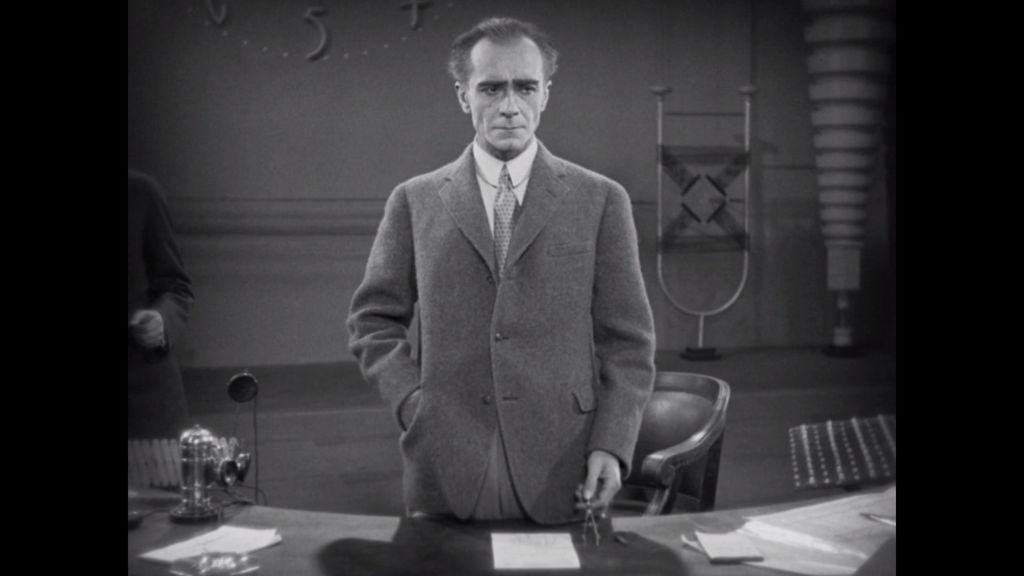Who is present in the image? There is a man in the image. What is the man doing in the image? The man is standing in front of a table. What is the man wearing in the image? The man is wearing a coat. What is on the table in the image? There is a paper on the table. What can be seen in the background of the image? There is a chair and a wall in the background of the image. What is the man wishing for in the image? There is no indication in the image that the man is wishing for anything. 